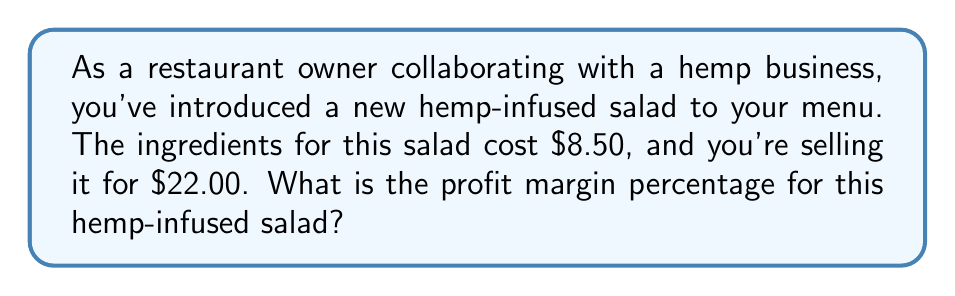Solve this math problem. To calculate the profit margin percentage, we need to follow these steps:

1. Calculate the profit:
   Profit = Selling price - Cost
   $$ \text{Profit} = $22.00 - $8.50 = $13.50 $$

2. Calculate the profit margin as a decimal:
   Profit margin (decimal) = Profit ÷ Selling price
   $$ \text{Profit margin} = \frac{$13.50}{$22.00} = 0.6136 $$

3. Convert the decimal to a percentage:
   Profit margin percentage = Profit margin (decimal) × 100%
   $$ \text{Profit margin percentage} = 0.6136 \times 100\% = 61.36\% $$

Therefore, the profit margin percentage for the hemp-infused salad is 61.36%.
Answer: 61.36% 